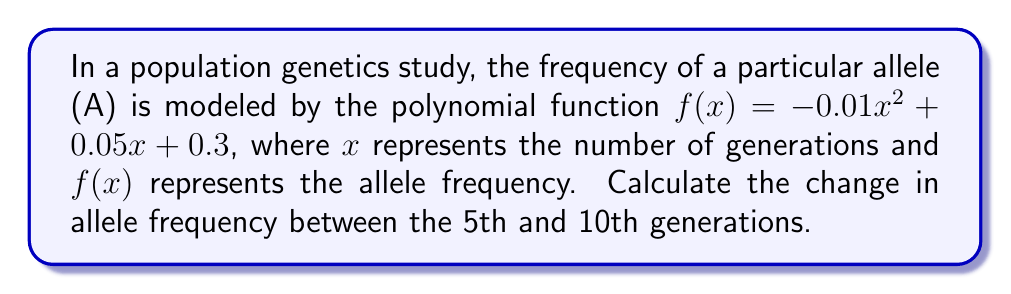Can you answer this question? To solve this problem, we need to follow these steps:

1) Calculate the allele frequency at the 5th generation:
   $f(5) = -0.01(5)^2 + 0.05(5) + 0.3$
   $= -0.01(25) + 0.25 + 0.3$
   $= -0.25 + 0.25 + 0.3$
   $= 0.3$

2) Calculate the allele frequency at the 10th generation:
   $f(10) = -0.01(10)^2 + 0.05(10) + 0.3$
   $= -0.01(100) + 0.5 + 0.3$
   $= -1 + 0.5 + 0.3$
   $= -0.2$

3) Calculate the change in allele frequency by subtracting the frequency at the 5th generation from the frequency at the 10th generation:

   Change = $f(10) - f(5) = -0.2 - 0.3 = -0.5$

The negative value indicates a decrease in allele frequency over this period.
Answer: The change in allele frequency between the 5th and 10th generations is $-0.5$. 